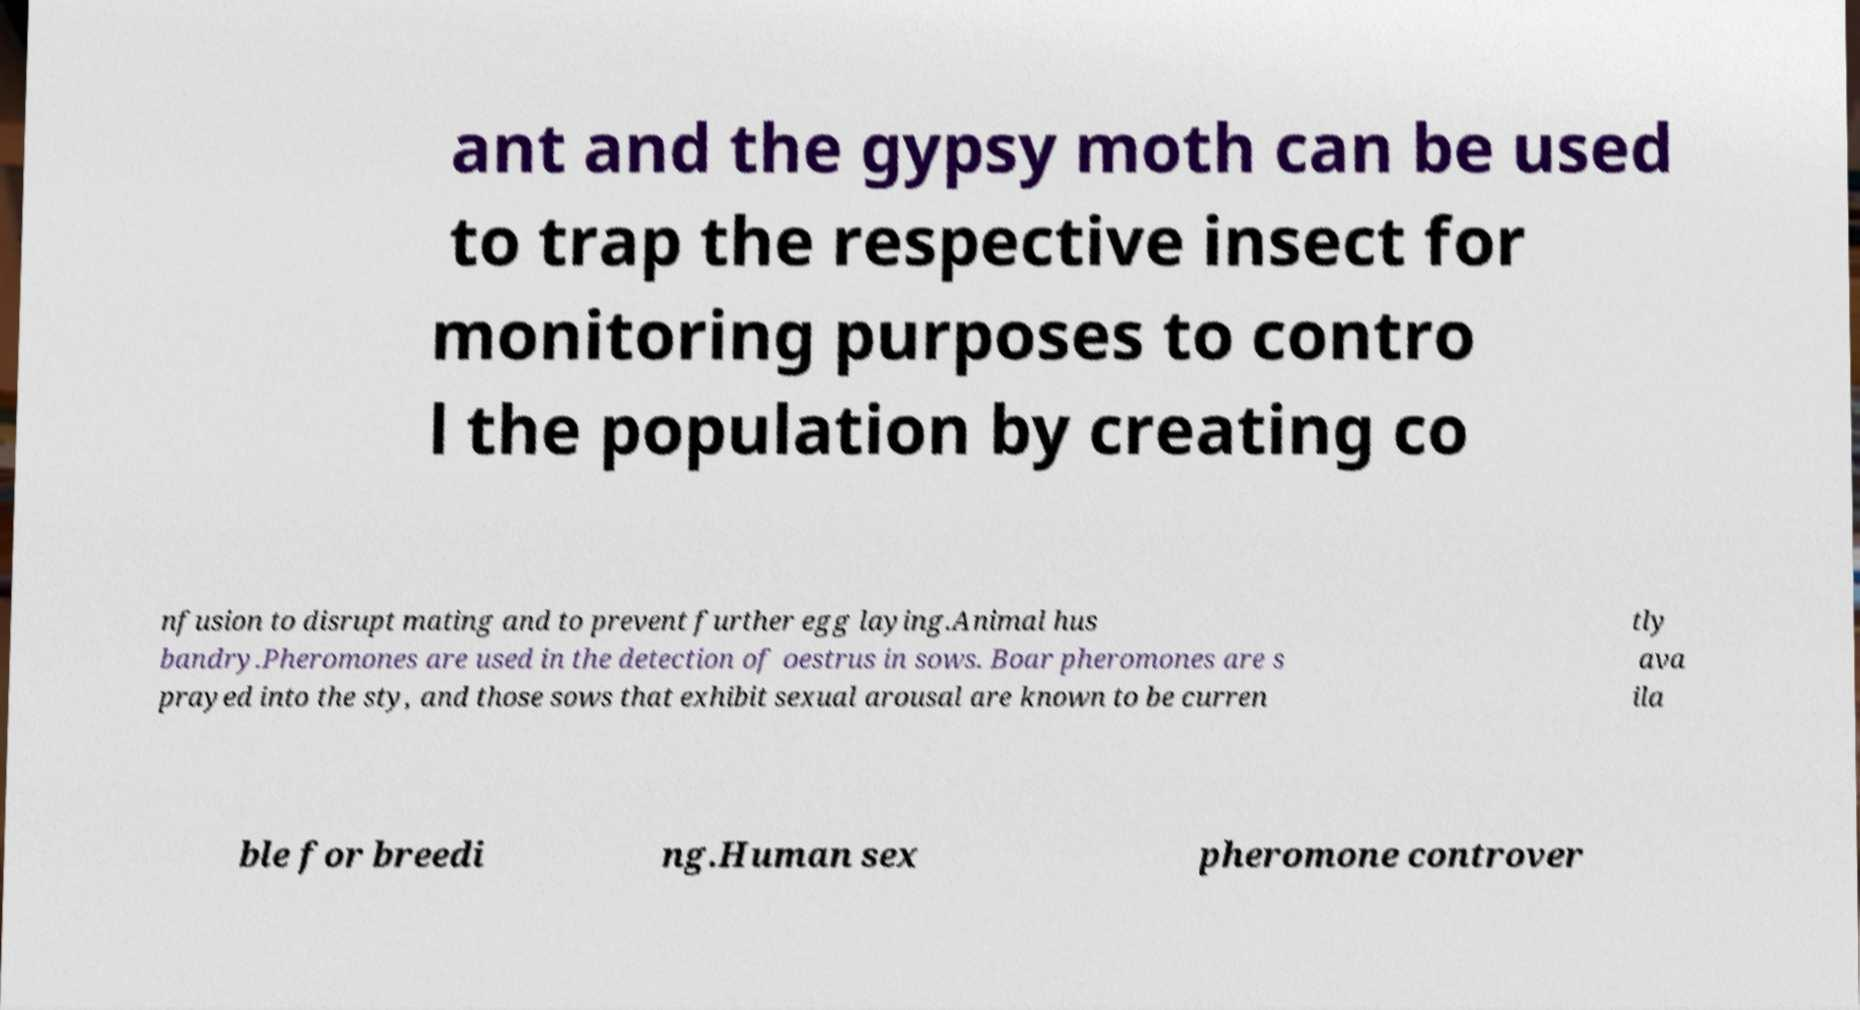I need the written content from this picture converted into text. Can you do that? ant and the gypsy moth can be used to trap the respective insect for monitoring purposes to contro l the population by creating co nfusion to disrupt mating and to prevent further egg laying.Animal hus bandry.Pheromones are used in the detection of oestrus in sows. Boar pheromones are s prayed into the sty, and those sows that exhibit sexual arousal are known to be curren tly ava ila ble for breedi ng.Human sex pheromone controver 